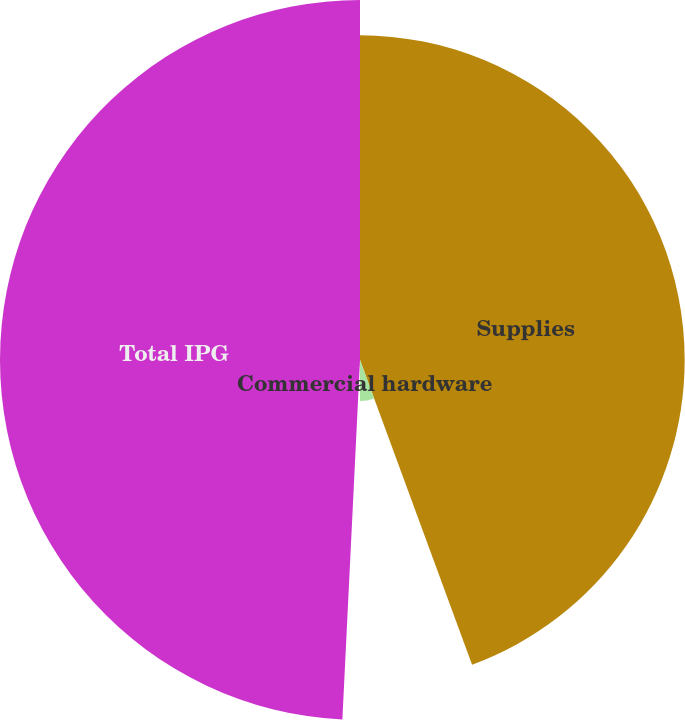<chart> <loc_0><loc_0><loc_500><loc_500><pie_chart><fcel>Supplies<fcel>Commercial hardware<fcel>Consumer hardware<fcel>Total IPG<nl><fcel>44.39%<fcel>5.61%<fcel>0.78%<fcel>49.22%<nl></chart> 